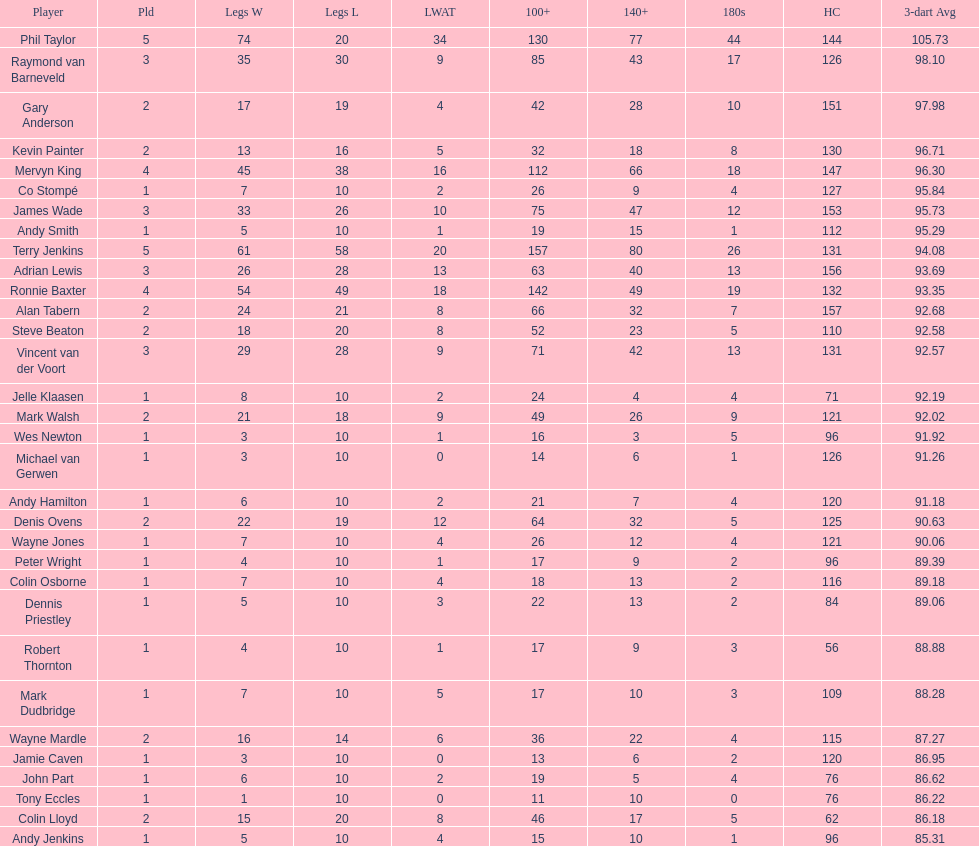Which player lost the least? Co Stompé, Andy Smith, Jelle Klaasen, Wes Newton, Michael van Gerwen, Andy Hamilton, Wayne Jones, Peter Wright, Colin Osborne, Dennis Priestley, Robert Thornton, Mark Dudbridge, Jamie Caven, John Part, Tony Eccles, Andy Jenkins. 